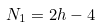Convert formula to latex. <formula><loc_0><loc_0><loc_500><loc_500>N _ { 1 } = 2 h - 4</formula> 